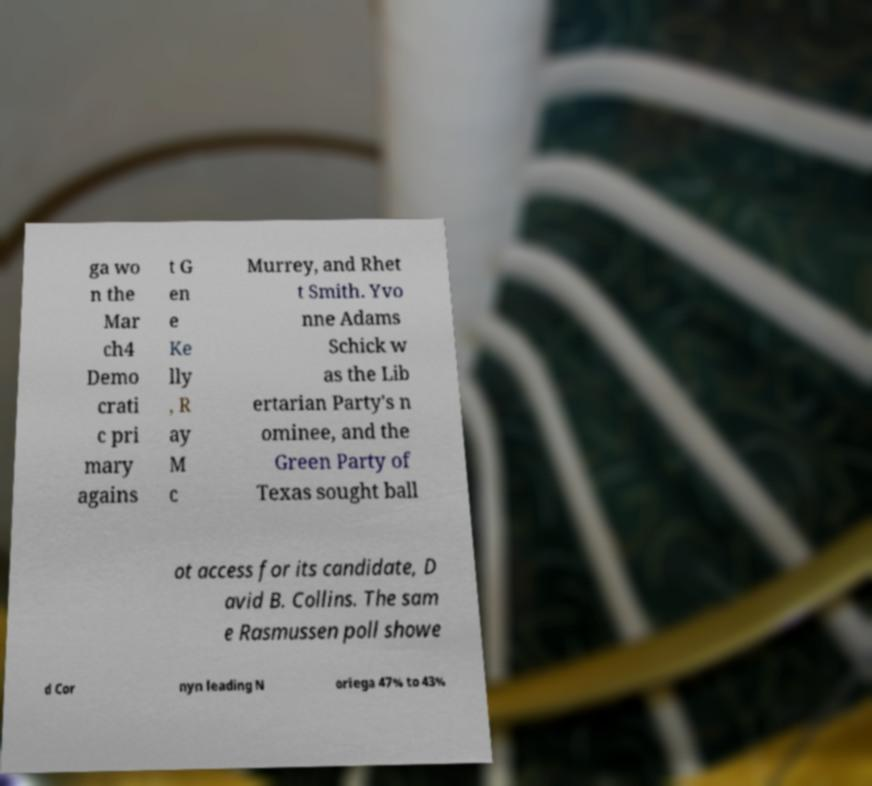Could you extract and type out the text from this image? ga wo n the Mar ch4 Demo crati c pri mary agains t G en e Ke lly , R ay M c Murrey, and Rhet t Smith. Yvo nne Adams Schick w as the Lib ertarian Party's n ominee, and the Green Party of Texas sought ball ot access for its candidate, D avid B. Collins. The sam e Rasmussen poll showe d Cor nyn leading N oriega 47% to 43% 